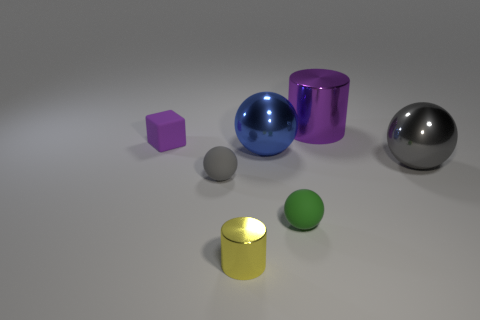Subtract all blue blocks. How many gray spheres are left? 2 Subtract all green balls. How many balls are left? 3 Subtract all cylinders. How many objects are left? 5 Add 2 purple cylinders. How many objects exist? 9 Subtract all green balls. Subtract all cyan cylinders. How many balls are left? 3 Subtract all big cyan rubber cubes. Subtract all big blue metal balls. How many objects are left? 6 Add 7 purple rubber cubes. How many purple rubber cubes are left? 8 Add 5 big blue things. How many big blue things exist? 6 Subtract 1 yellow cylinders. How many objects are left? 6 